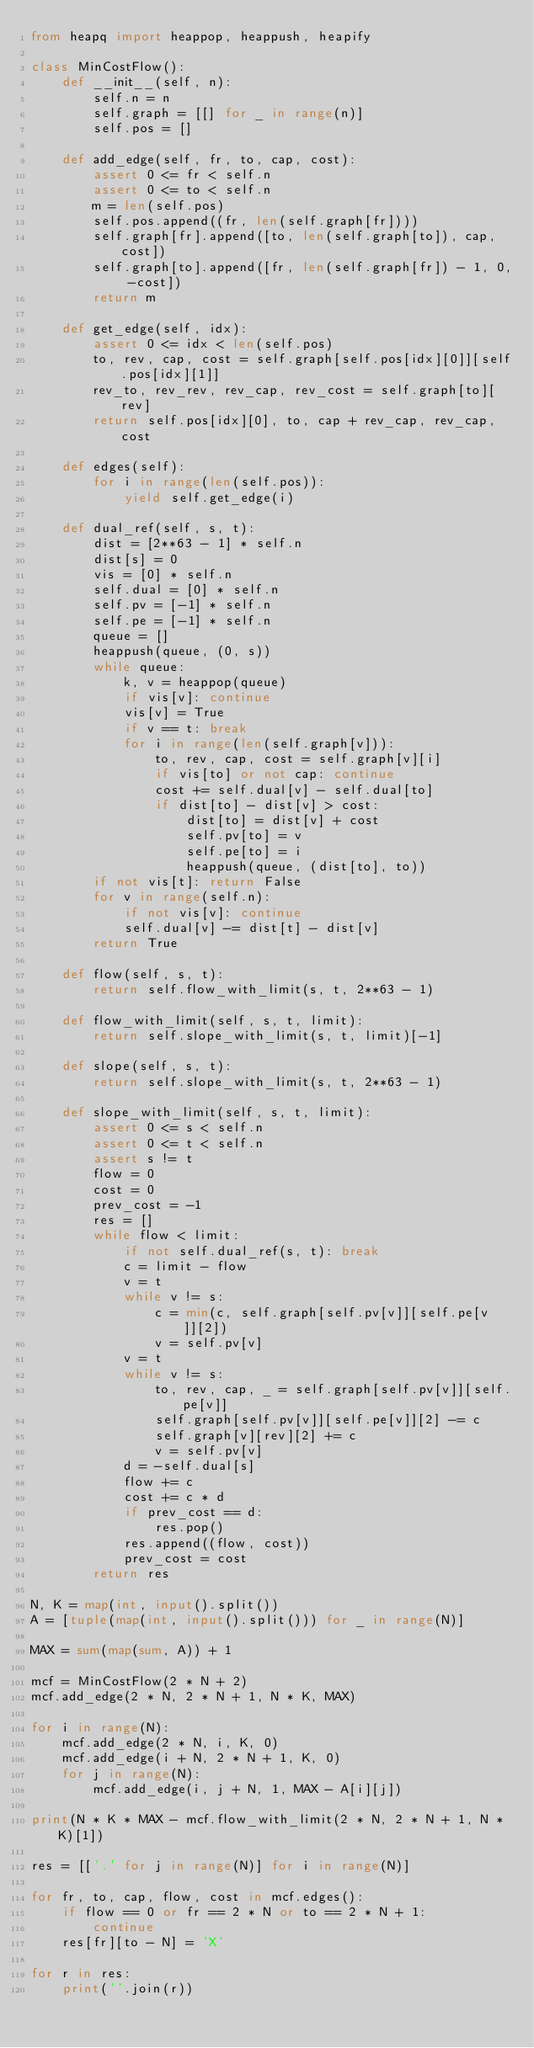Convert code to text. <code><loc_0><loc_0><loc_500><loc_500><_Python_>from heapq import heappop, heappush, heapify

class MinCostFlow():
    def __init__(self, n):
        self.n = n
        self.graph = [[] for _ in range(n)]
        self.pos = []

    def add_edge(self, fr, to, cap, cost):
        assert 0 <= fr < self.n
        assert 0 <= to < self.n
        m = len(self.pos)
        self.pos.append((fr, len(self.graph[fr])))
        self.graph[fr].append([to, len(self.graph[to]), cap, cost])
        self.graph[to].append([fr, len(self.graph[fr]) - 1, 0, -cost])
        return m

    def get_edge(self, idx):
        assert 0 <= idx < len(self.pos)
        to, rev, cap, cost = self.graph[self.pos[idx][0]][self.pos[idx][1]]
        rev_to, rev_rev, rev_cap, rev_cost = self.graph[to][rev]
        return self.pos[idx][0], to, cap + rev_cap, rev_cap, cost

    def edges(self):
        for i in range(len(self.pos)):
            yield self.get_edge(i)

    def dual_ref(self, s, t):
        dist = [2**63 - 1] * self.n
        dist[s] = 0
        vis = [0] * self.n
        self.dual = [0] * self.n
        self.pv = [-1] * self.n
        self.pe = [-1] * self.n
        queue = []
        heappush(queue, (0, s))
        while queue:
            k, v = heappop(queue)
            if vis[v]: continue
            vis[v] = True
            if v == t: break
            for i in range(len(self.graph[v])):
                to, rev, cap, cost = self.graph[v][i]
                if vis[to] or not cap: continue
                cost += self.dual[v] - self.dual[to]
                if dist[to] - dist[v] > cost:
                    dist[to] = dist[v] + cost
                    self.pv[to] = v
                    self.pe[to] = i
                    heappush(queue, (dist[to], to))
        if not vis[t]: return False
        for v in range(self.n):
            if not vis[v]: continue
            self.dual[v] -= dist[t] - dist[v]
        return True

    def flow(self, s, t):
        return self.flow_with_limit(s, t, 2**63 - 1)

    def flow_with_limit(self, s, t, limit):
        return self.slope_with_limit(s, t, limit)[-1]

    def slope(self, s, t):
        return self.slope_with_limit(s, t, 2**63 - 1)

    def slope_with_limit(self, s, t, limit):
        assert 0 <= s < self.n
        assert 0 <= t < self.n
        assert s != t
        flow = 0
        cost = 0
        prev_cost = -1
        res = []
        while flow < limit:
            if not self.dual_ref(s, t): break
            c = limit - flow
            v = t
            while v != s:
                c = min(c, self.graph[self.pv[v]][self.pe[v]][2])
                v = self.pv[v]
            v = t
            while v != s:
                to, rev, cap, _ = self.graph[self.pv[v]][self.pe[v]]
                self.graph[self.pv[v]][self.pe[v]][2] -= c
                self.graph[v][rev][2] += c
                v = self.pv[v]
            d = -self.dual[s]
            flow += c
            cost += c * d
            if prev_cost == d:
                res.pop()
            res.append((flow, cost))
            prev_cost = cost
        return res

N, K = map(int, input().split())
A = [tuple(map(int, input().split())) for _ in range(N)]

MAX = sum(map(sum, A)) + 1

mcf = MinCostFlow(2 * N + 2)
mcf.add_edge(2 * N, 2 * N + 1, N * K, MAX)

for i in range(N):
    mcf.add_edge(2 * N, i, K, 0)
    mcf.add_edge(i + N, 2 * N + 1, K, 0)
    for j in range(N):
        mcf.add_edge(i, j + N, 1, MAX - A[i][j])

print(N * K * MAX - mcf.flow_with_limit(2 * N, 2 * N + 1, N * K)[1])

res = [['.' for j in range(N)] for i in range(N)]

for fr, to, cap, flow, cost in mcf.edges():
    if flow == 0 or fr == 2 * N or to == 2 * N + 1:
        continue
    res[fr][to - N] = 'X'

for r in res:
    print(''.join(r))</code> 